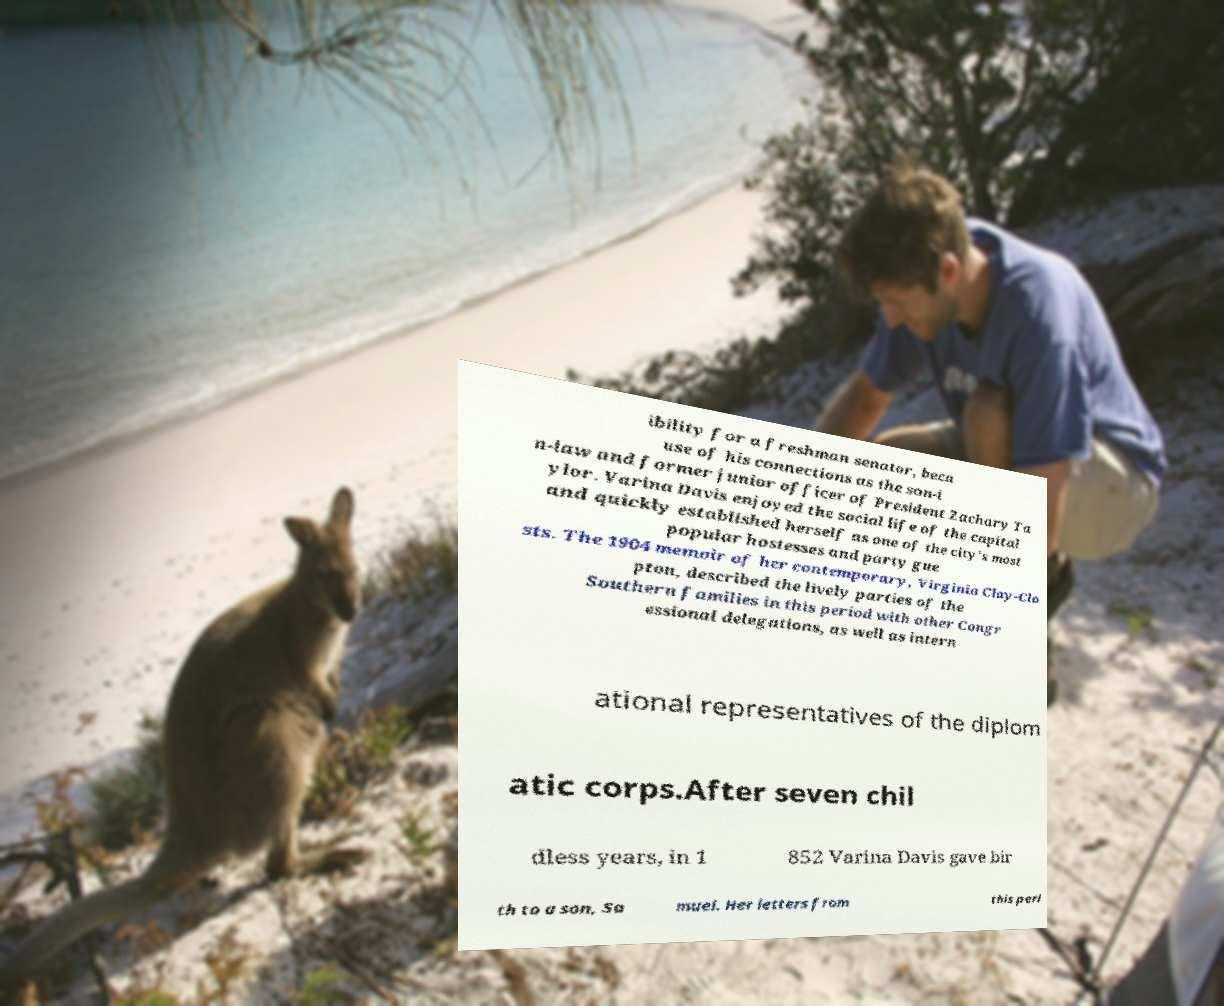Can you read and provide the text displayed in the image?This photo seems to have some interesting text. Can you extract and type it out for me? ibility for a freshman senator, beca use of his connections as the son-i n-law and former junior officer of President Zachary Ta ylor. Varina Davis enjoyed the social life of the capital and quickly established herself as one of the city's most popular hostesses and party gue sts. The 1904 memoir of her contemporary, Virginia Clay-Clo pton, described the lively parties of the Southern families in this period with other Congr essional delegations, as well as intern ational representatives of the diplom atic corps.After seven chil dless years, in 1 852 Varina Davis gave bir th to a son, Sa muel. Her letters from this peri 